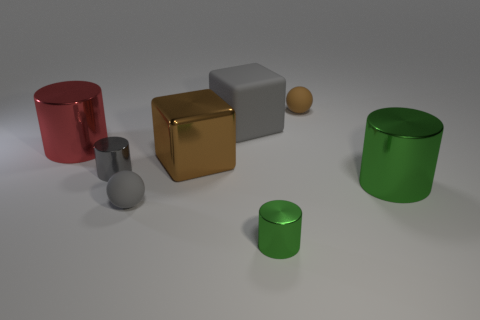What color is the other small object that is the same shape as the gray shiny thing?
Ensure brevity in your answer.  Green. There is a cylinder that is in front of the small sphere in front of the red metallic cylinder; how many small things are on the left side of it?
Offer a very short reply. 2. Is there any other thing that has the same material as the tiny green object?
Offer a very short reply. Yes. Are there fewer green cylinders that are to the left of the metal block than large purple rubber spheres?
Give a very brief answer. No. Is the color of the big metallic block the same as the rubber cube?
Your response must be concise. No. What size is the other rubber thing that is the same shape as the small brown thing?
Your response must be concise. Small. How many tiny green objects have the same material as the large green object?
Give a very brief answer. 1. Is the big brown thing in front of the large red cylinder made of the same material as the red thing?
Your response must be concise. Yes. Is the number of brown things in front of the tiny brown thing the same as the number of gray rubber things?
Offer a very short reply. No. What is the size of the red shiny thing?
Your answer should be very brief. Large. 